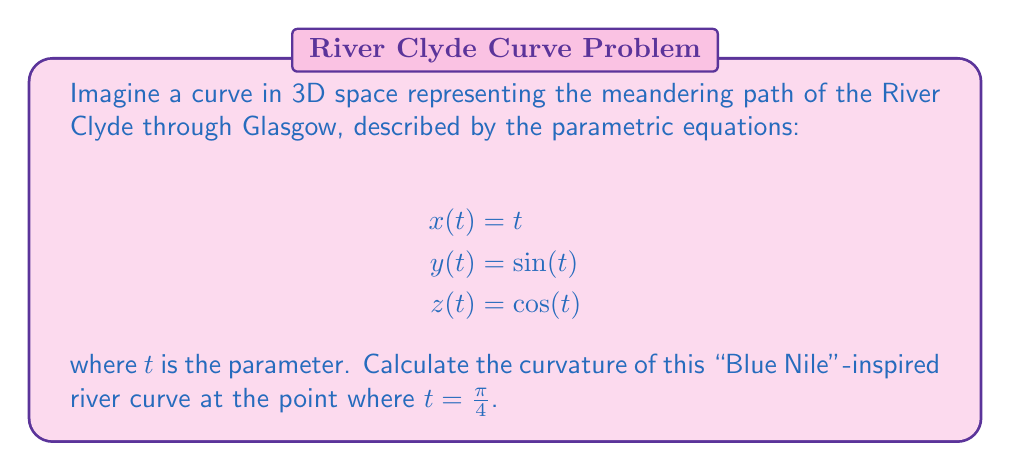Show me your answer to this math problem. To calculate the curvature of a 3D curve, we'll use the formula:

$$\kappa = \frac{\|\mathbf{r}'(t) \times \mathbf{r}''(t)\|}{\|\mathbf{r}'(t)\|^3}$$

where $\mathbf{r}(t) = (x(t), y(t), z(t))$ is the position vector.

Step 1: Calculate $\mathbf{r}'(t)$ and $\mathbf{r}''(t)$
$\mathbf{r}'(t) = (1, \cos(t), -\sin(t))$
$\mathbf{r}''(t) = (0, -\sin(t), -\cos(t))$

Step 2: Calculate $\mathbf{r}'(t) \times \mathbf{r}''(t)$
$$\mathbf{r}'(t) \times \mathbf{r}''(t) = \begin{vmatrix} 
\mathbf{i} & \mathbf{j} & \mathbf{k} \\
1 & \cos(t) & -\sin(t) \\
0 & -\sin(t) & -\cos(t)
\end{vmatrix}$$

$= (-\cos^2(t) - \sin^2(t))\mathbf{i} + \sin(t)\mathbf{j} + \cos(t)\mathbf{k}$

$= -\mathbf{i} + \sin(t)\mathbf{j} + \cos(t)\mathbf{k}$

Step 3: Calculate $\|\mathbf{r}'(t) \times \mathbf{r}''(t)\|$
$\|\mathbf{r}'(t) \times \mathbf{r}''(t)\| = \sqrt{1 + \sin^2(t) + \cos^2(t)} = \sqrt{2}$

Step 4: Calculate $\|\mathbf{r}'(t)\|$
$\|\mathbf{r}'(t)\| = \sqrt{1 + \cos^2(t) + \sin^2(t)} = \sqrt{2}$

Step 5: Apply the curvature formula at $t = \frac{\pi}{4}$
$$\kappa = \frac{\|\mathbf{r}'(t) \times \mathbf{r}''(t)\|}{\|\mathbf{r}'(t)\|^3} = \frac{\sqrt{2}}{(\sqrt{2})^3} = \frac{1}{2}$$

Therefore, the curvature of the river-like curve at $t = \frac{\pi}{4}$ is $\frac{1}{2}$.
Answer: $\frac{1}{2}$ 